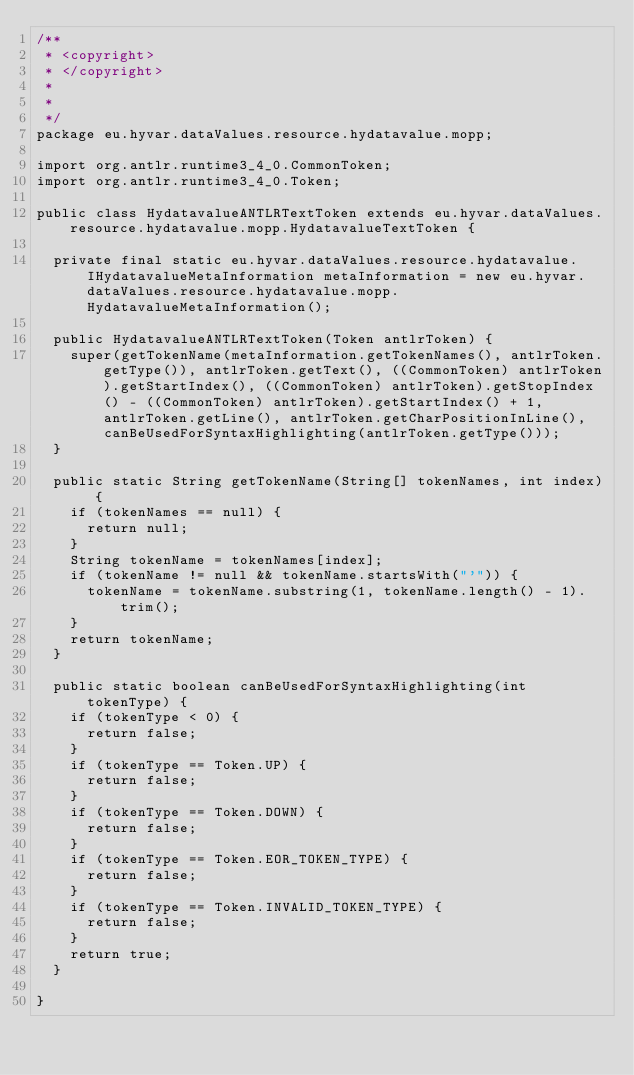<code> <loc_0><loc_0><loc_500><loc_500><_Java_>/**
 * <copyright>
 * </copyright>
 *
 * 
 */
package eu.hyvar.dataValues.resource.hydatavalue.mopp;

import org.antlr.runtime3_4_0.CommonToken;
import org.antlr.runtime3_4_0.Token;

public class HydatavalueANTLRTextToken extends eu.hyvar.dataValues.resource.hydatavalue.mopp.HydatavalueTextToken {
	
	private final static eu.hyvar.dataValues.resource.hydatavalue.IHydatavalueMetaInformation metaInformation = new eu.hyvar.dataValues.resource.hydatavalue.mopp.HydatavalueMetaInformation();
	
	public HydatavalueANTLRTextToken(Token antlrToken) {
		super(getTokenName(metaInformation.getTokenNames(), antlrToken.getType()), antlrToken.getText(), ((CommonToken) antlrToken).getStartIndex(), ((CommonToken) antlrToken).getStopIndex() - ((CommonToken) antlrToken).getStartIndex() + 1, antlrToken.getLine(), antlrToken.getCharPositionInLine(), canBeUsedForSyntaxHighlighting(antlrToken.getType()));
	}
	
	public static String getTokenName(String[] tokenNames, int index) {
		if (tokenNames == null) {
			return null;
		}
		String tokenName = tokenNames[index];
		if (tokenName != null && tokenName.startsWith("'")) {
			tokenName = tokenName.substring(1, tokenName.length() - 1).trim();
		}
		return tokenName;
	}
	
	public static boolean canBeUsedForSyntaxHighlighting(int tokenType) {
		if (tokenType < 0) {
			return false;
		}
		if (tokenType == Token.UP) {
			return false;
		}
		if (tokenType == Token.DOWN) {
			return false;
		}
		if (tokenType == Token.EOR_TOKEN_TYPE) {
			return false;
		}
		if (tokenType == Token.INVALID_TOKEN_TYPE) {
			return false;
		}
		return true;
	}
	
}
</code> 